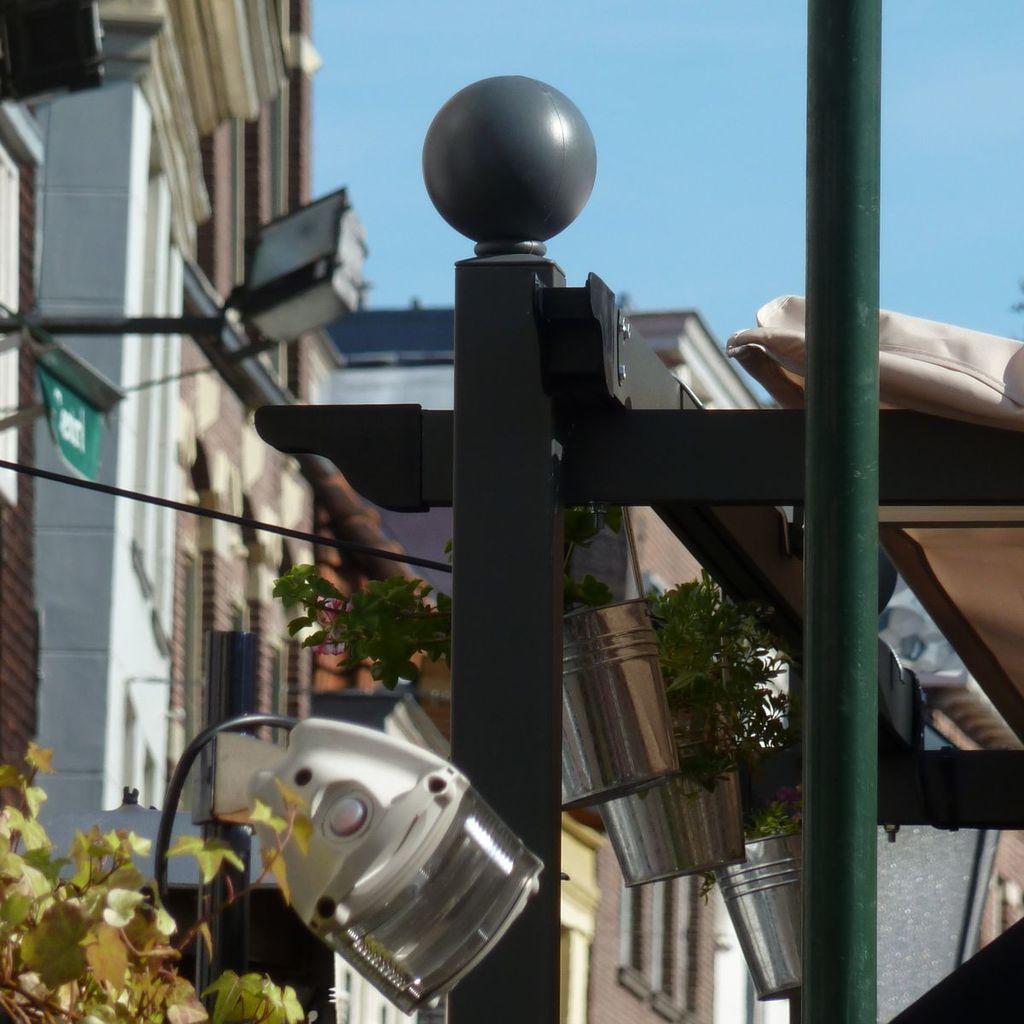Could you give a brief overview of what you see in this image? This image is clicked outside. There are plants in the middle. There are buildings in the middle. There is sky at the top. There is light at the bottom. 